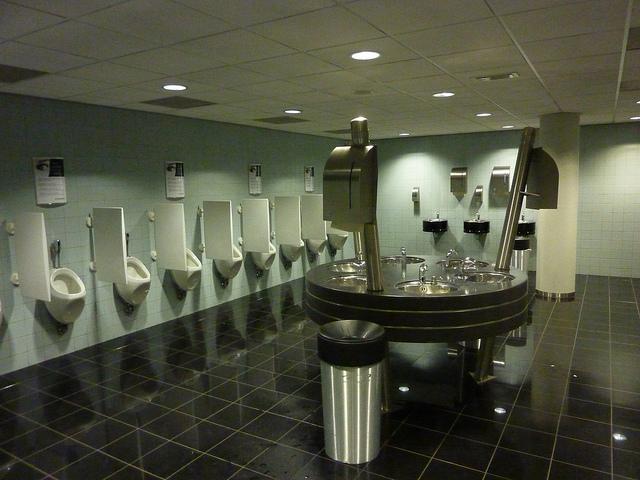What brand of sink is this?
Answer briefly. Kohler. What are the things called on the left wall?
Quick response, please. Urinals. What color is the trash bin?
Answer briefly. Silver. What color is the garbage can?
Give a very brief answer. Silver. How do you know this is not a unisex bathroom?
Be succinct. Urinals. Is this a celebration?
Concise answer only. No. Is the bathroom clean?
Quick response, please. Yes. What goes inside these objects?
Keep it brief. Urine. 